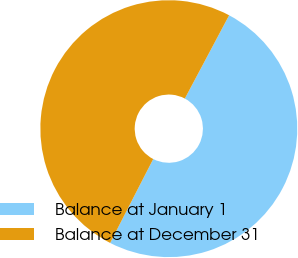<chart> <loc_0><loc_0><loc_500><loc_500><pie_chart><fcel>Balance at January 1<fcel>Balance at December 31<nl><fcel>49.77%<fcel>50.23%<nl></chart> 